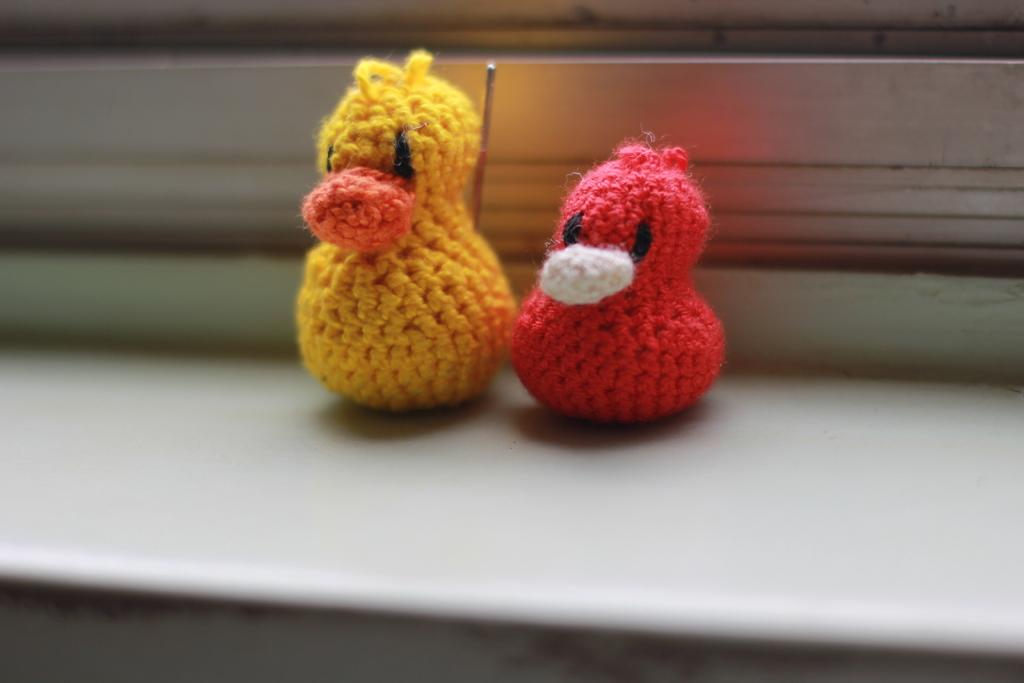What is the main subject in the center of the image? There is a platform in the center of the image. What can be seen on the platform? There are two woolen toys on toys on the platform. How can you differentiate between the two toys? The toys have different colors. Can you describe the background of the image? The background of the image is blurred. How do the sisters interact with the straw in the image? There are no sisters or straw present in the image. 